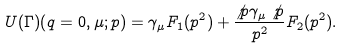<formula> <loc_0><loc_0><loc_500><loc_500>U ( \Gamma ) ( q = 0 , \mu ; p ) = \gamma _ { \mu } F _ { 1 } ( p ^ { 2 } ) + \frac { \not { p } \gamma _ { \mu } \not { p } } { p ^ { 2 } } F _ { 2 } ( p ^ { 2 } ) .</formula> 